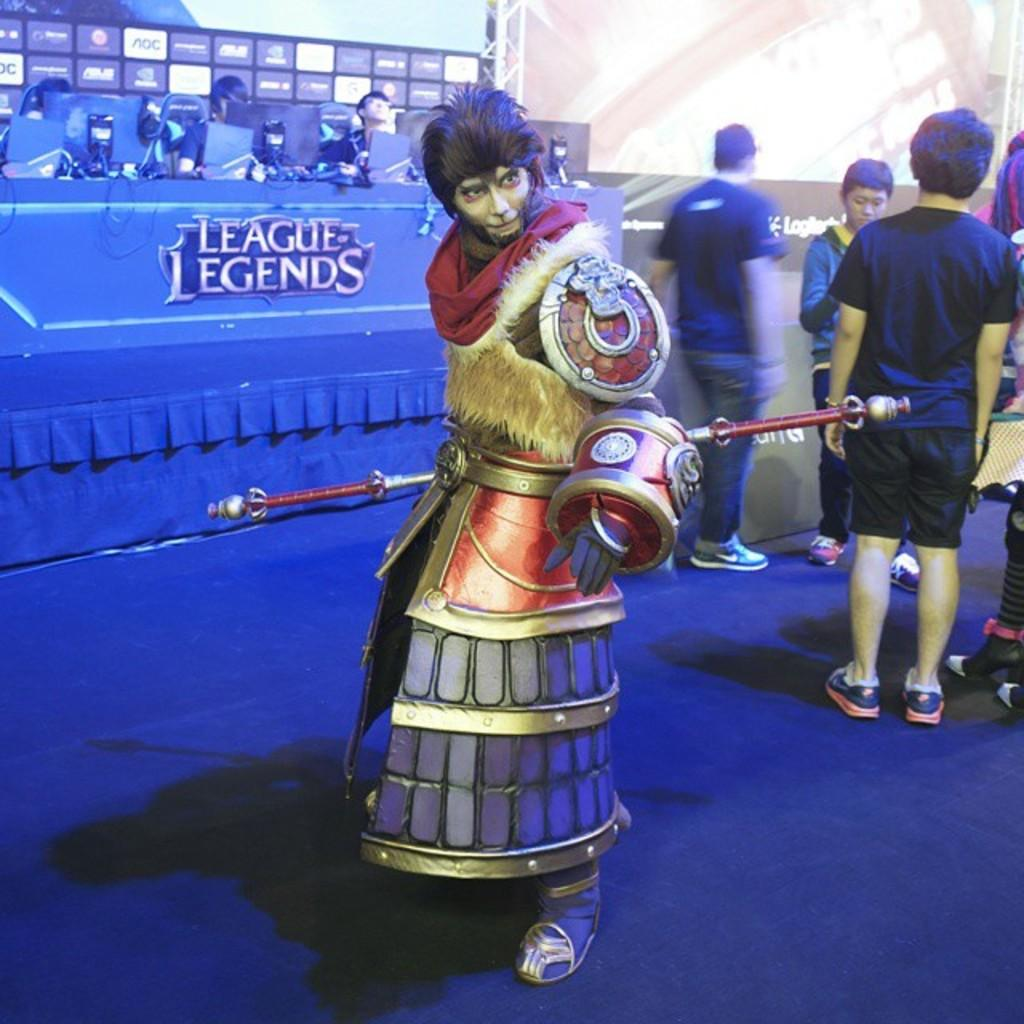What is the main subject in the center of the image? There is a statue in the center of the image. What are the people in the background doing? The persons in the background are standing and sitting. What electronic devices can be seen in the background of the image? There are laptops visible in the background of the image. What kind of information is displayed on the board in the background? There is a board with text written on it in the background of the image. What color is the skirt worn by the statue in the image? The statue in the image is not wearing a skirt, as it is a non-living object and does not wear clothing. 